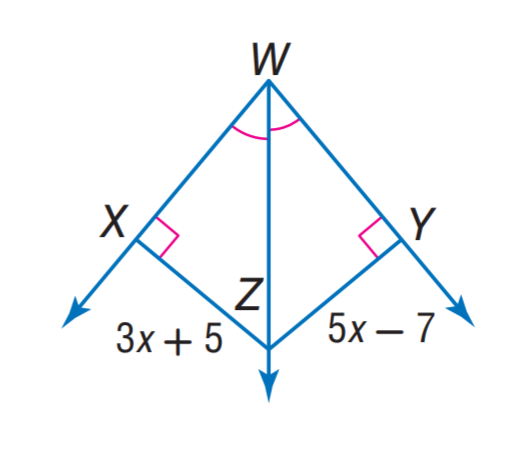Answer the mathemtical geometry problem and directly provide the correct option letter.
Question: Find X Z.
Choices: A: 5 B: 15 C: 23 D: 35 C 